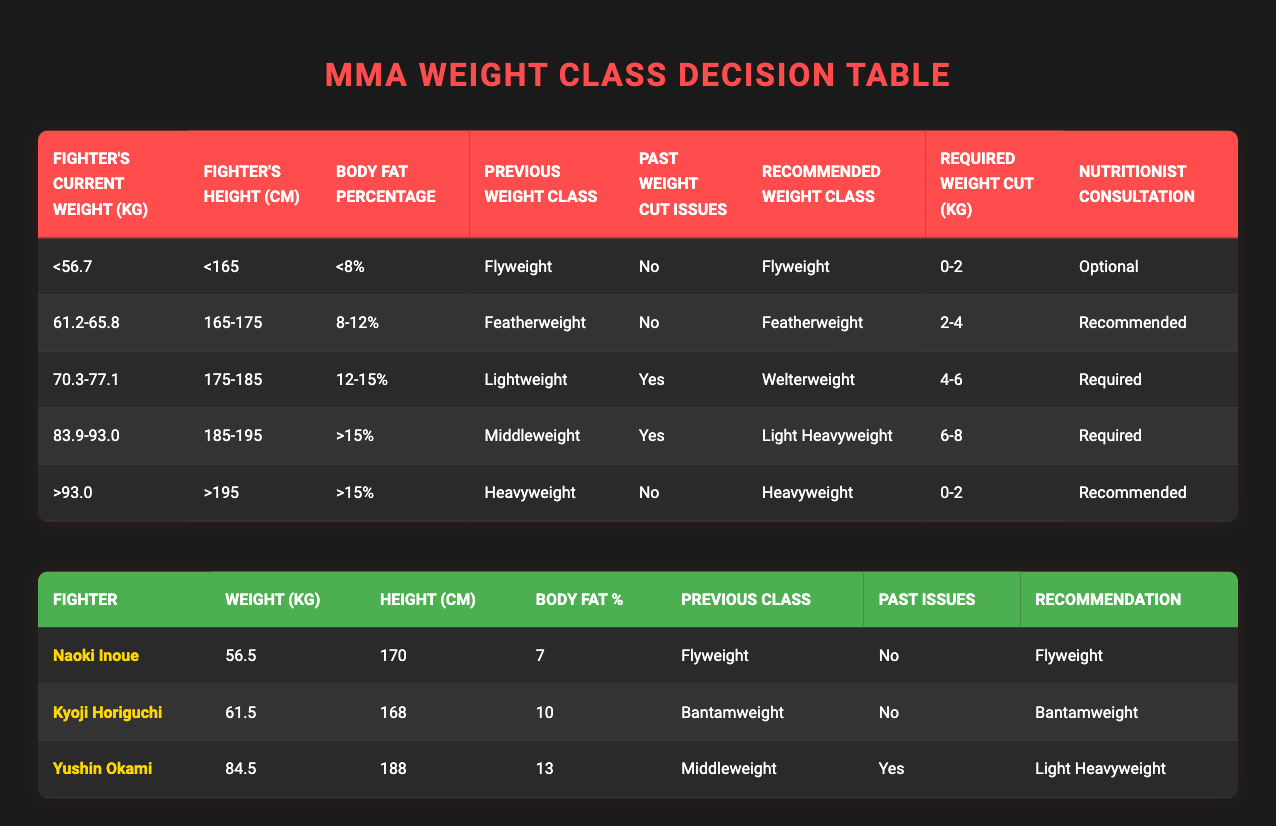What is the recommended weight class for a fighter weighing 84.5 kg? According to the table, a fighter weighing 84.5 kg falls into the category of "83.9-93.0" kg, combined with their height of "185-195" cm, a body fat percentage of "13%", and being from the "Middleweight" class with past weight cut issues marked as "Yes," which leads to the recommendation of the "Light Heavyweight" class.
Answer: Light Heavyweight How many fighters have past weight cut issues and are recommended for the "Welterweight" class? Referring to the table, the "Welterweight" class is recommended for a fighter weighing "70.3-77.1" kg, with a height of "175-185" cm, a body fat percentage of "12-15%", and past weight cut issues marked as "Yes." From the data, only "Yushin Okami" fits this criteria. Thus, there is one fighter with these conditions.
Answer: 1 Does a fighter who weighs over 93.0 kg and has more than 15% body fat require a nutritionist consultation? According to the table, fighters over "93.0" kg with ">15%" body fat and have a previous weight class of "Heavyweight" and past weight cut issues marked as "No," have a nutritionist consultation marked as "Recommended." Thus, a fighter in this category does indeed require a nutritionist consultation.
Answer: Yes What is the average weight for the fighters mentioned in the examples? The weights of the three fighters are as follows: Naoki Inoue at 56.5 kg, Kyoji Horiguchi at 61.5 kg, and Yushin Okami at 84.5 kg. To find the average, we sum these weights (56.5 + 61.5 + 84.5 = 202.5 kg) and divide by the number of fighters (202.5 / 3 = 67.5 kg). Therefore, the average weight of the mentioned fighters is 67.5 kg.
Answer: 67.5 kg What is the required weight cut for a fighter recommended for the Featherweight class? The Featherweight class is recommended for fighters weighing "61.2-65.8" kg, "165-175" cm tall, with a body fat percentage of "8-12%", and previous weight class marked as "Featherweight" without past issues. The only relevant entry states that the required weight cut is "2-4 kg."
Answer: 2-4 kg 